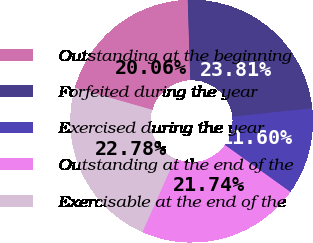Convert chart to OTSL. <chart><loc_0><loc_0><loc_500><loc_500><pie_chart><fcel>Outstanding at the beginning<fcel>Forfeited during the year<fcel>Exercised during the year<fcel>Outstanding at the end of the<fcel>Exercisable at the end of the<nl><fcel>20.06%<fcel>23.81%<fcel>11.6%<fcel>21.74%<fcel>22.78%<nl></chart> 